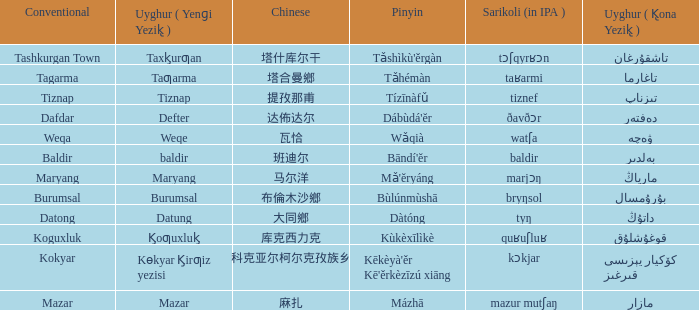Name the conventional for defter Dafdar. 